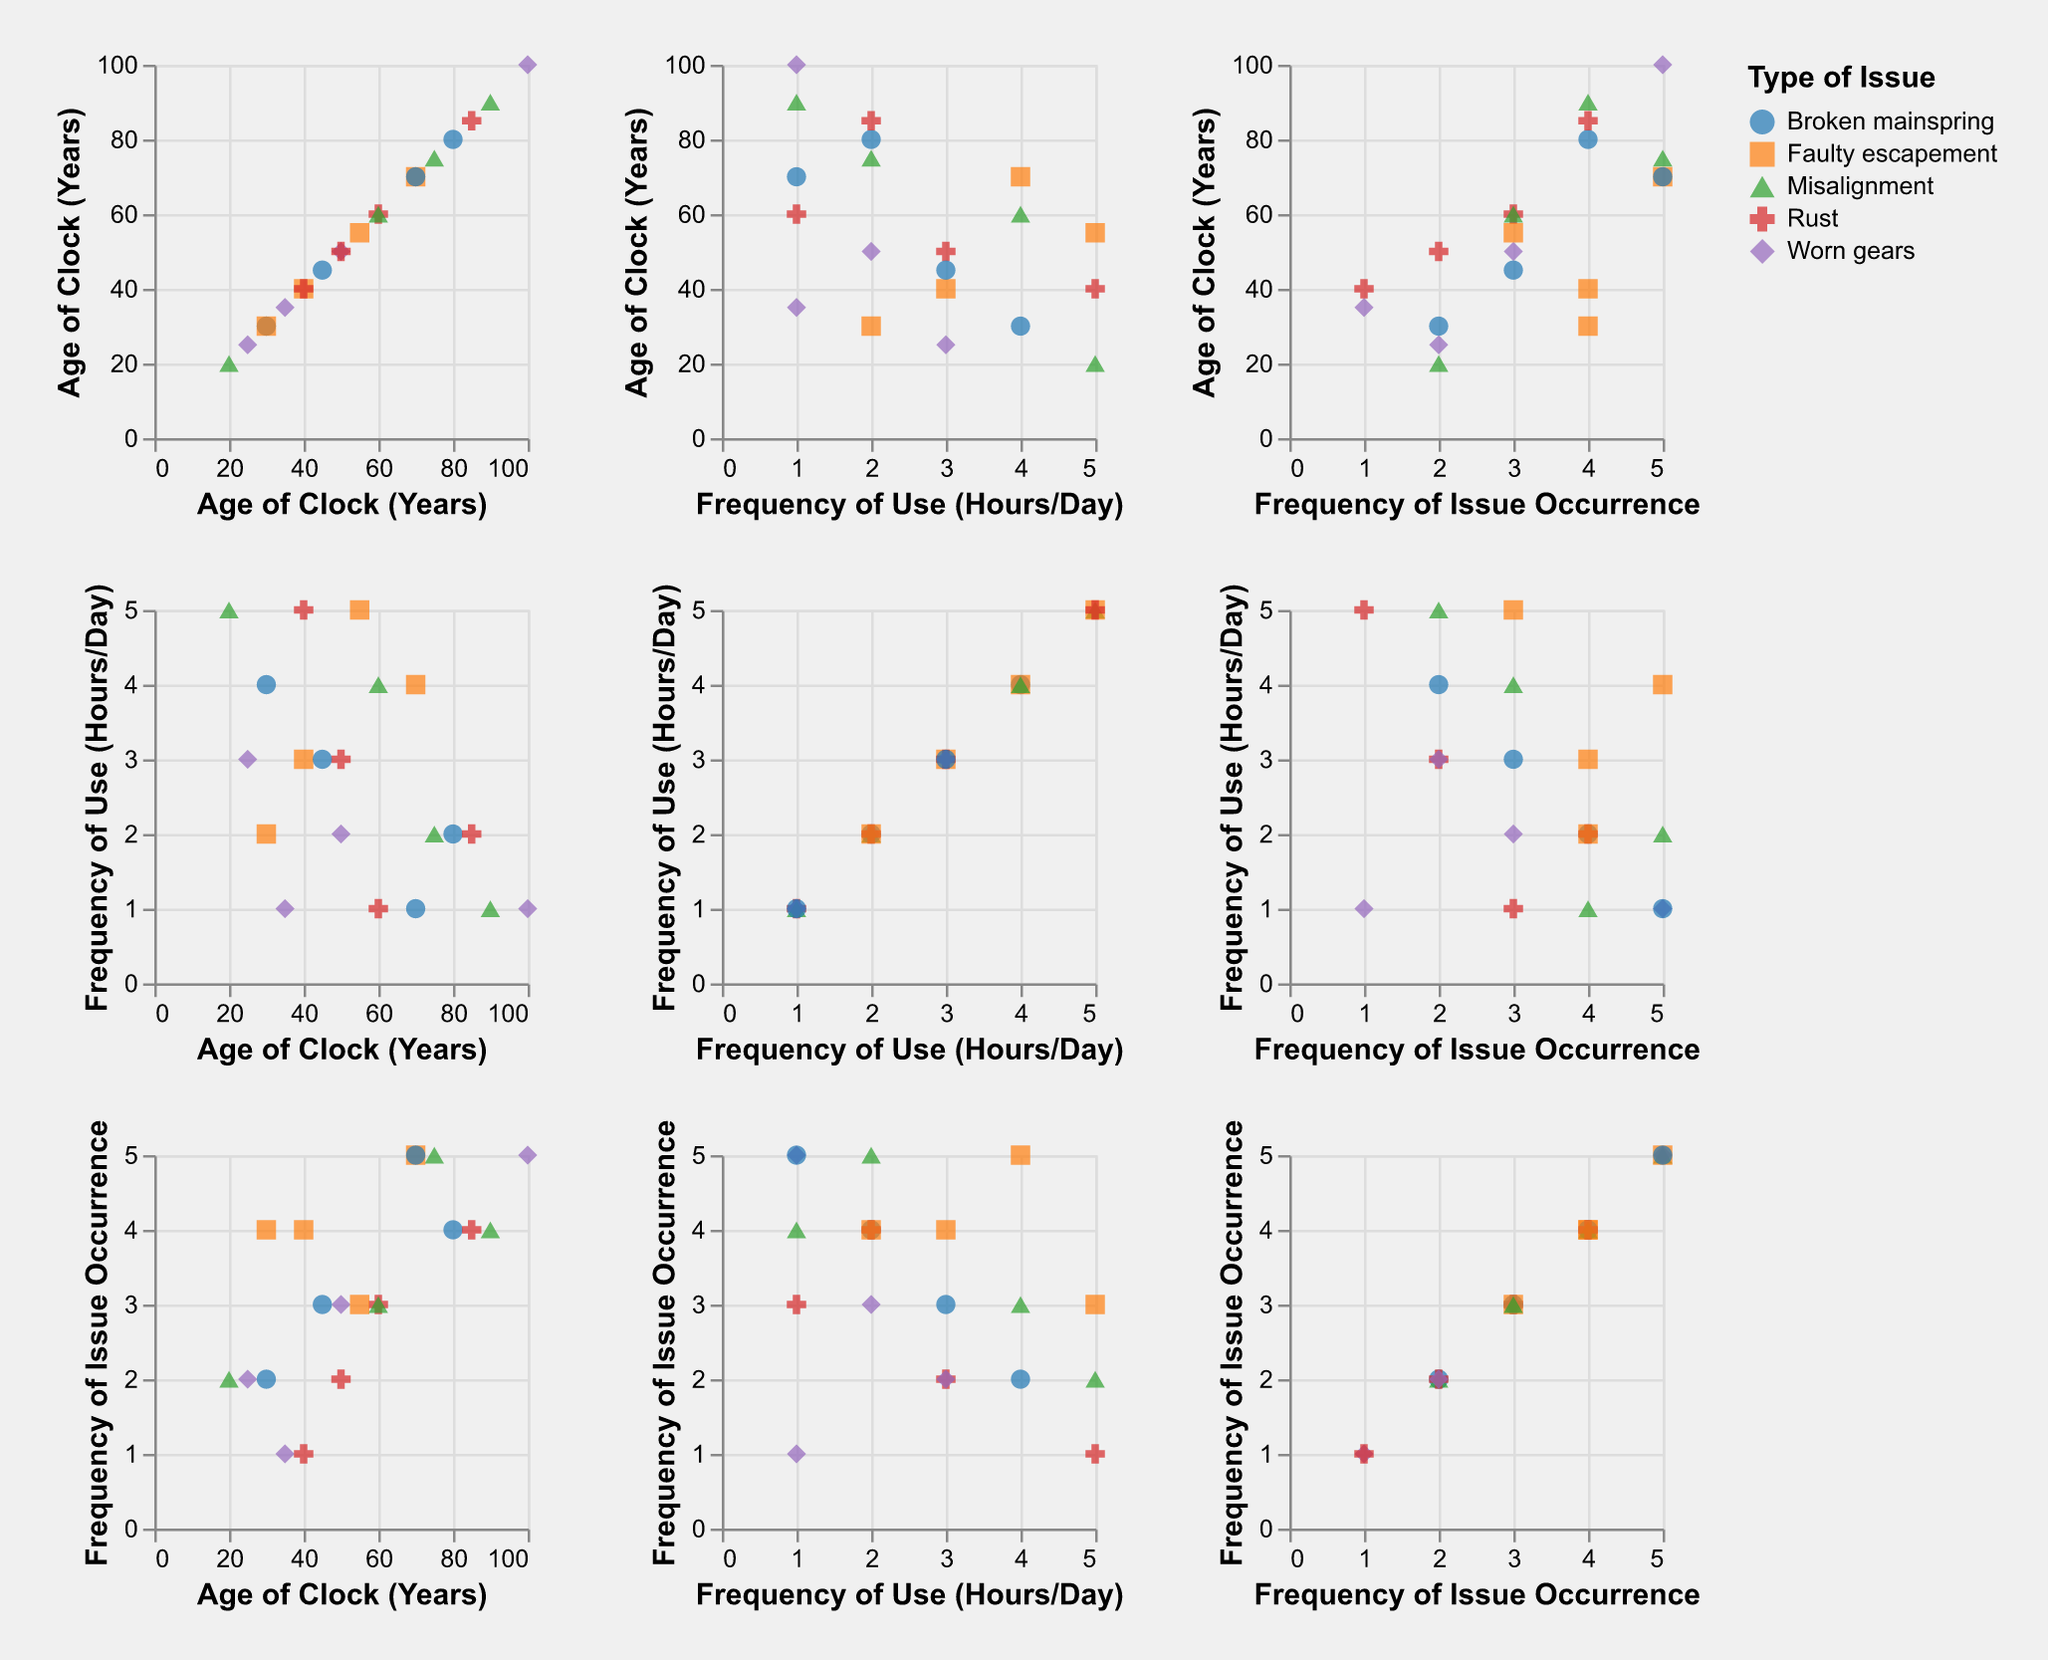What's the title of the figure? The title is usually found at the top of the figure, summarizing the main subject.
Answer: Frequency of Repair Issues in Mechanical Clocks: Type of Issue vs. Age of Clock vs. Frequency of Use How many different types of issues are displayed in the scatter plot matrix? To determine this, look at the unique categories in the legend or the different colors/shapes used in the plot.
Answer: 5 What is the Frequency of Issue Occurrence for a clock with Rust that is 85 years old? Locate the data point in the plot where the age is 85 and the issue type is Rust, then check the Frequency of Issue Occurrence value.
Answer: 4 Which type of issue appears more frequently as the age of the clock increases? To answer this, observe the scatter plots that have Age of Clock on the x-axis and compare the density or clustering of the points corresponding to each issue type.
Answer: Misalignment What is the relationship between the Frequency of Use and the Frequency of Issue Occurrence? Examine the scatter plots with Frequency of Use on one axis and Frequency of Issue Occurrence on the other to see if there's a visible trend, such as a positive or negative correlation.
Answer: No clear trend For clocks with a Frequency of Use of 3 hours per day, which type of issue has the highest Frequency of Issue Occurrence? Isolate the data points where the Frequency of Use is 3 and compare their corresponding Frequency of Issue Occurrence, then identify the type of issue.
Answer: Faulty escapement Which age group of clocks shows the most diverse types of issues? Look at the plots with Age of Clock on one axis and observe which age range has the most varied colors/shapes representing different issues.
Answer: 30-45 years Does a higher Frequency of Use necessarily mean a higher Frequency of Issue Occurrence for Worn Gears? Focus on the Worn Gears data points and compare their Frequency of Use values against their Frequency of Issue Occurrence to check for any consistent patterns.
Answer: No What is the average Frequency of Issue Occurrence for clocks older than 70 years? Identify the data points where Age of Clock is greater than 70, sum their Frequency of Issue Occurrence values, and divide by the number of such data points.
Answer: 4.167 For a clock with Broken Mainspring used for 2 hours per day, what is its Age of Clock? Locate the data point where the Type of Issue is Broken Mainspring and Frequency of Use is 2, then check the Age of Clock value.
Answer: 80 years 